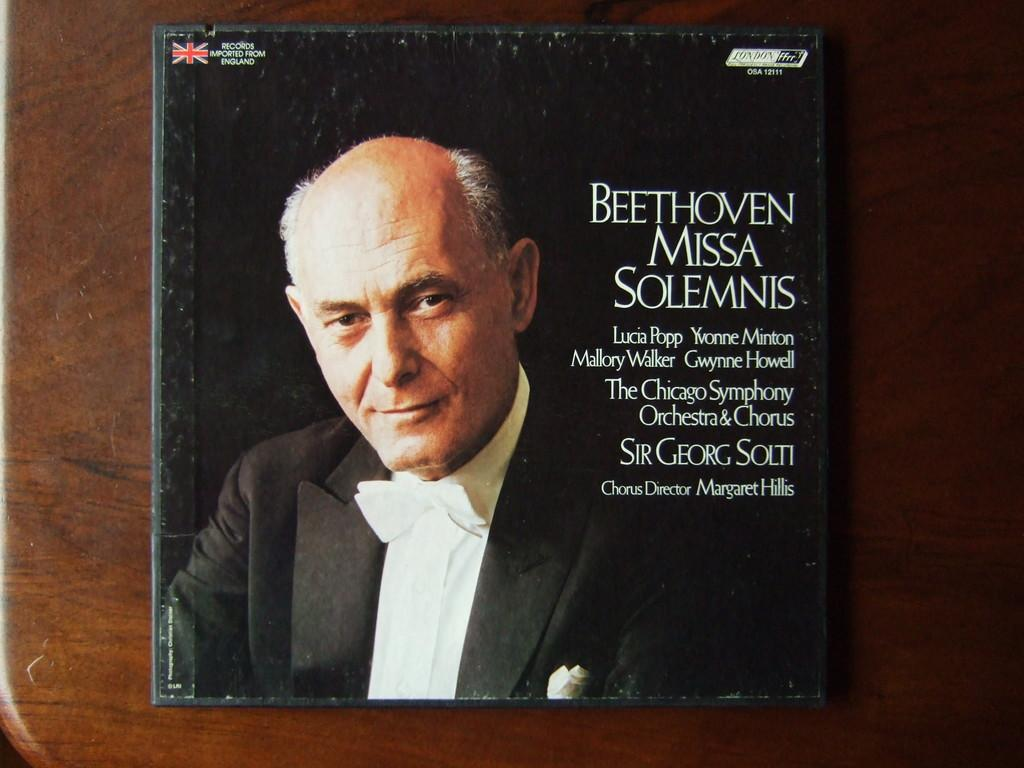<image>
Render a clear and concise summary of the photo. cd of Beethoven Missa Solemnis with a picture of older man in a tuxedo on it 